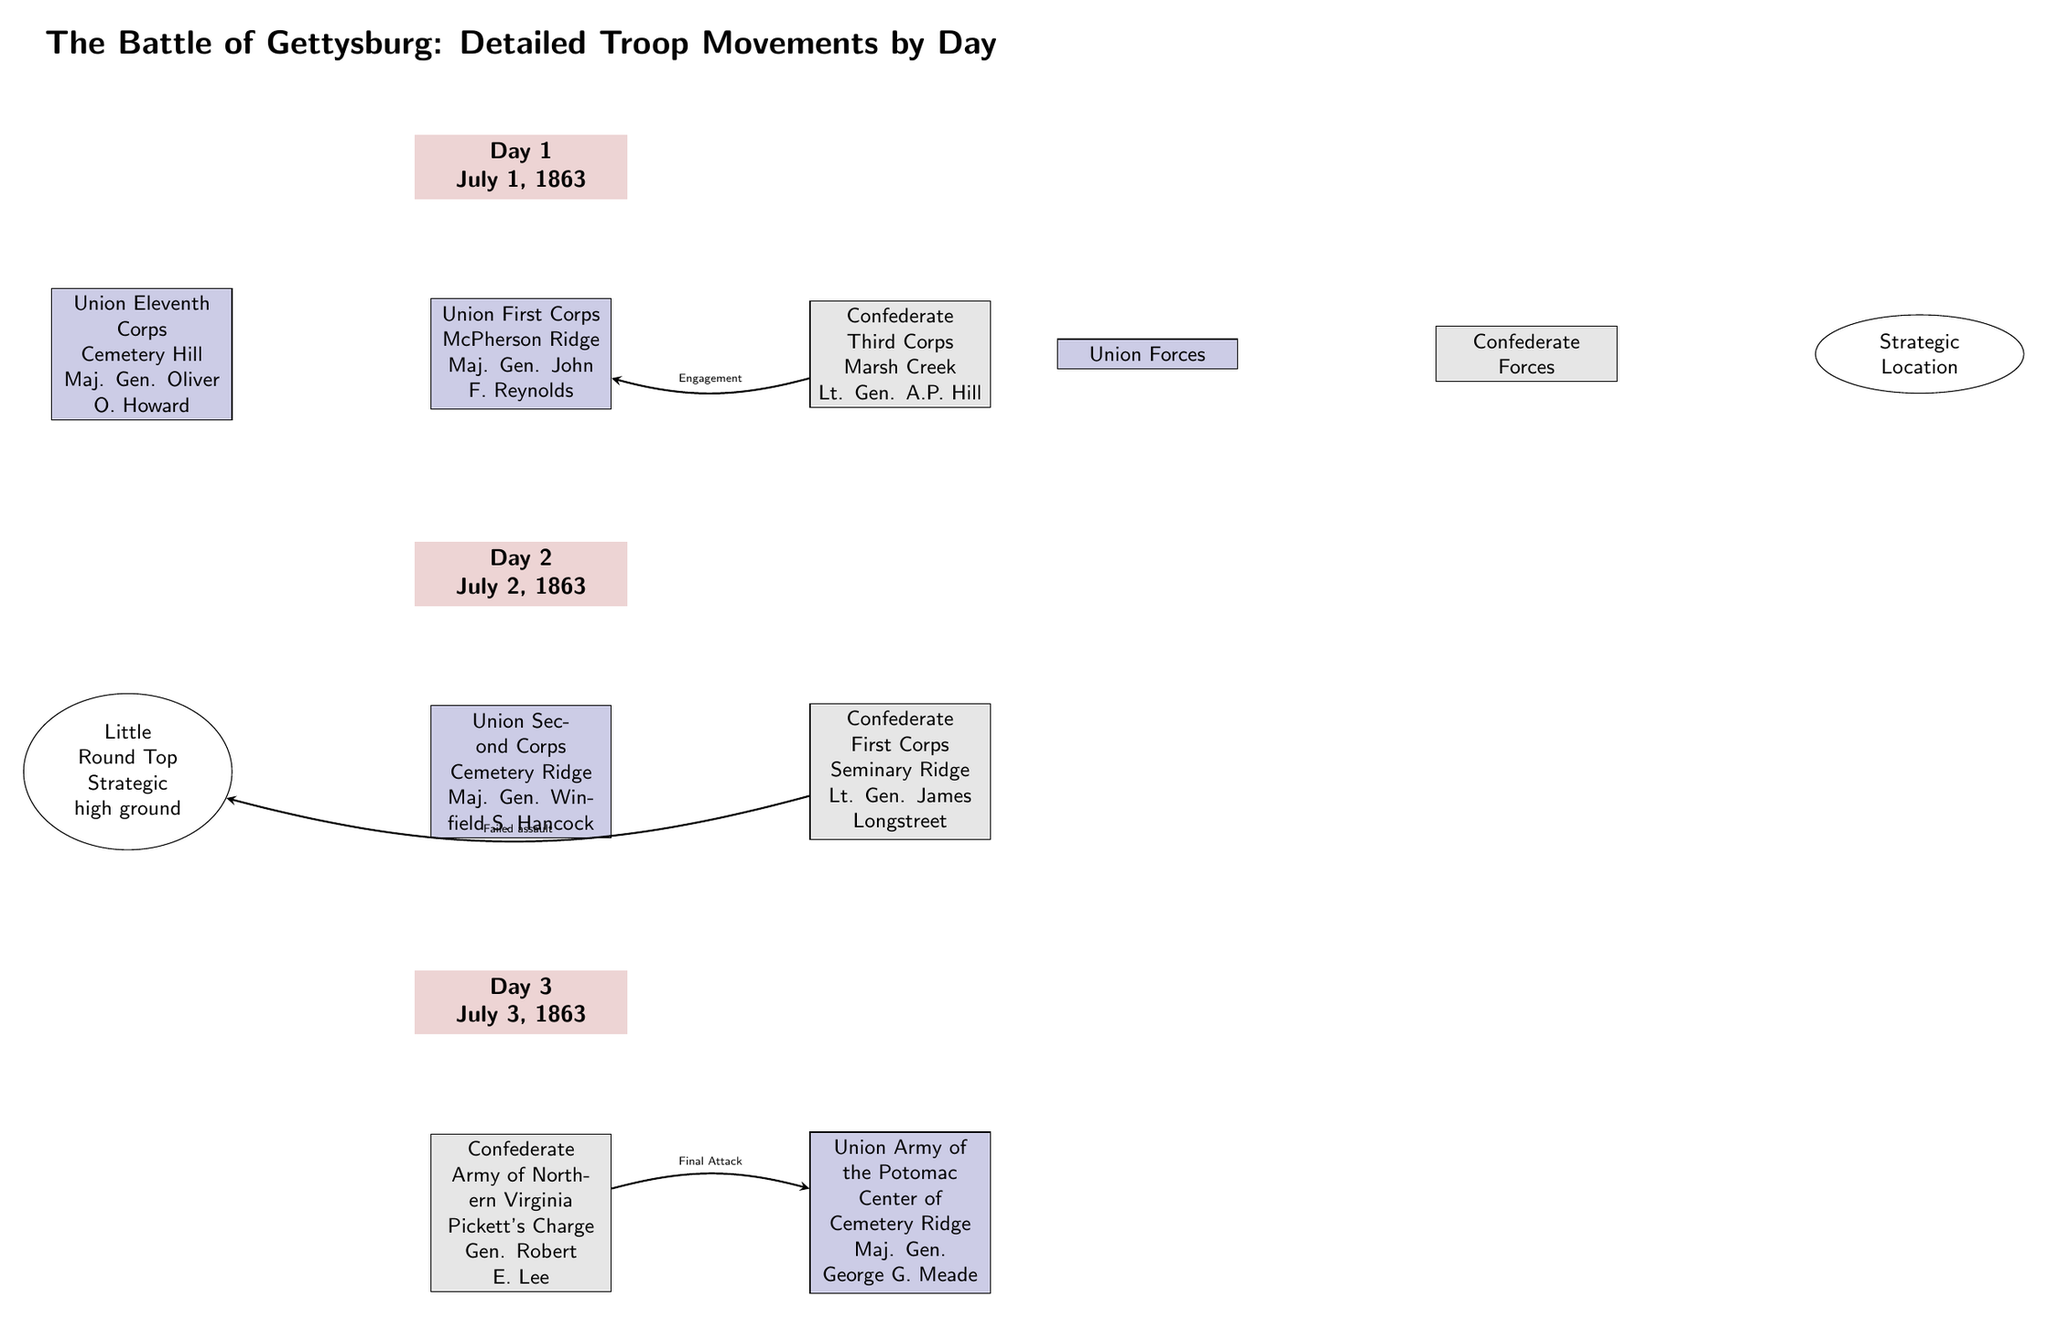What date does Day 1 of the Battle of Gettysburg take place? The diagram indicates that Day 1 is labeled with the date "July 1, 1863." This information can be found directly on the Day 1 node at the top of the diagram.
Answer: July 1, 1863 Which Union corps was stationed at Cemetery Hill on Day 1? The diagram shows that the Union Eleventh Corps, led by Maj. Gen. Oliver O. Howard, was positioned at Cemetery Hill on Day 1. This is indicated in the left node associated with Day 1.
Answer: Union Eleventh Corps How many main combat units are shown on Day 2 of the diagram? The diagram lists three combat units during Day 2: Union Second Corps, Confederate First Corps, and the location of Little Round Top. This can be determined by counting the numbered units and locations under Day 2.
Answer: 3 What event connects the Confederate forces to Union forces on Day 1? The diagram indicates an "Engagement" connects the Confederate Third Corps to the Union First Corps. This is detailed by the arrow labeled "Engagement" between those two units in Day 1.
Answer: Engagement Which strategic location is highlighted during Day 2? The diagram specifically identifies "Little Round Top" as the strategic high ground on Day 2, illustrated to the left of the Union Second Corps unit in that section of the diagram.
Answer: Little Round Top What is the name of the Confederate general leading the final attack on Day 3? According to the diagram, the final attack on Day 3, marked as "Pickett's Charge," is led by Gen. Robert E. Lee, which can be seen in the node for Confederate Army of Northern Virginia under Day 3.
Answer: Gen. Robert E. Lee What is the color representing Union forces in the diagram? The color representing Union forces in the diagram is a shade of blue, specifically labeled with the color definition "unionblue" in the code. This is visible in the filled units for the Union forces across the diagram.
Answer: Union blue What type of attack does the diagram describe for Day 3? The diagram describes the final attack on Day 3 as "Final Attack," specifically referring to Pickett's Charge against Union forces, indicated by the notation in the Day 3 connections.
Answer: Final Attack 